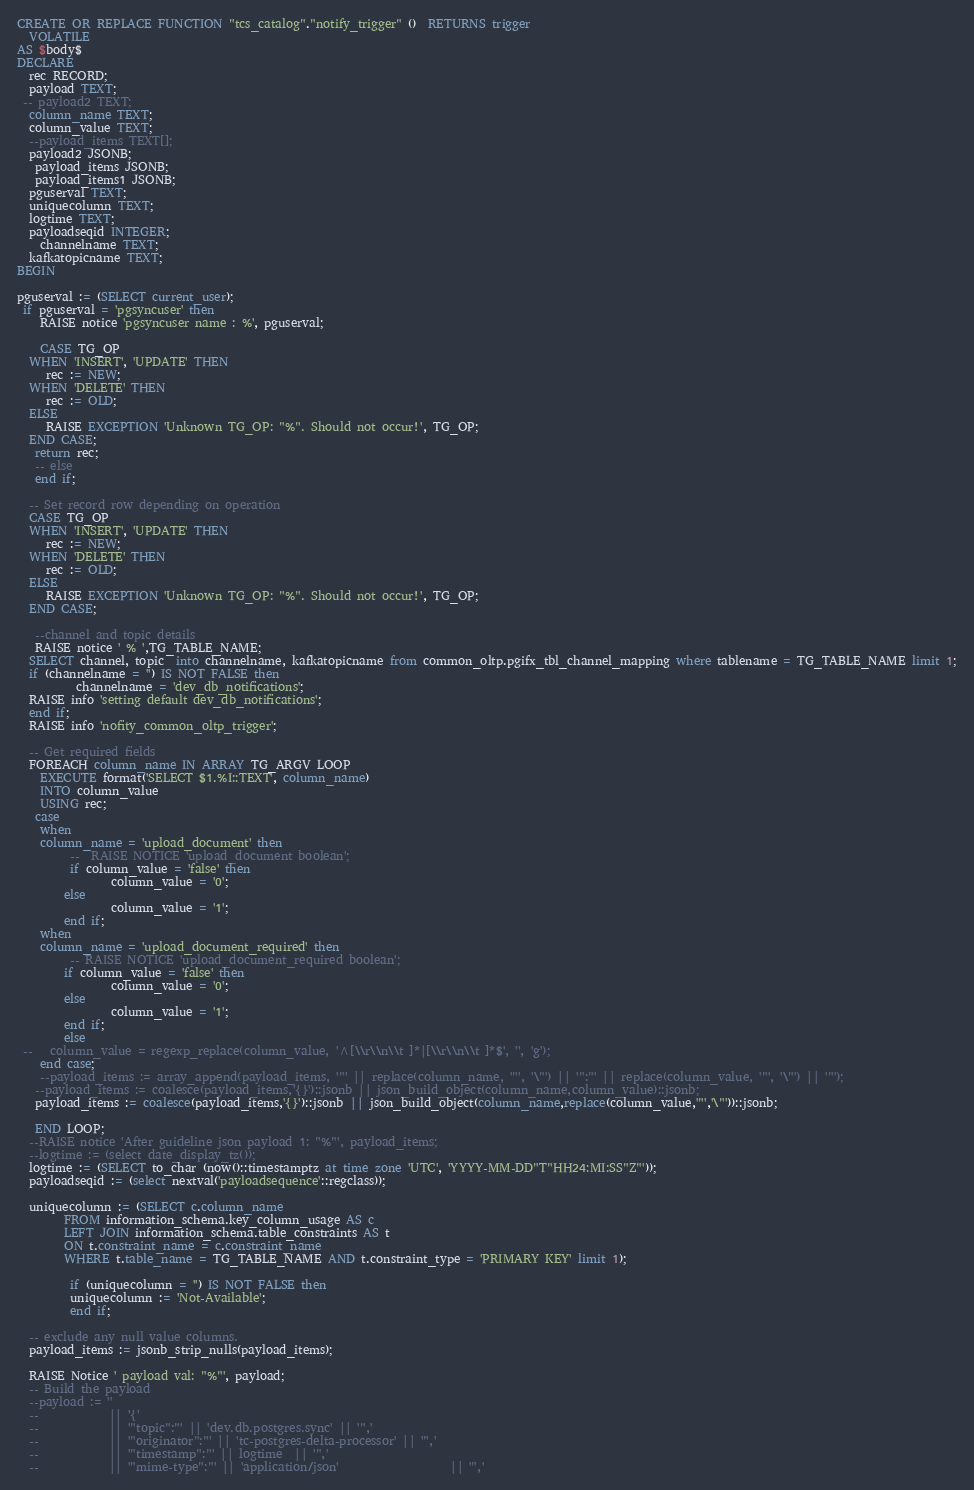Convert code to text. <code><loc_0><loc_0><loc_500><loc_500><_SQL_>CREATE OR REPLACE FUNCTION "tcs_catalog"."notify_trigger" ()  RETURNS trigger
  VOLATILE
AS $body$
DECLARE
  rec RECORD;
  payload TEXT;
 -- payload2 TEXT;
  column_name TEXT;
  column_value TEXT;
  --payload_items TEXT[];
  payload2 JSONB;
   payload_items JSONB;
   payload_items1 JSONB;
  pguserval TEXT;
  uniquecolumn TEXT;
  logtime TEXT;
  payloadseqid INTEGER;
    channelname TEXT;
  kafkatopicname TEXT;
BEGIN

pguserval := (SELECT current_user);
 if pguserval = 'pgsyncuser' then
    RAISE notice 'pgsyncuser name : %', pguserval;
   
    CASE TG_OP
  WHEN 'INSERT', 'UPDATE' THEN
     rec := NEW;
  WHEN 'DELETE' THEN
     rec := OLD;
  ELSE
     RAISE EXCEPTION 'Unknown TG_OP: "%". Should not occur!', TG_OP;
  END CASE;
   return rec;
   -- else
   end if;
   
  -- Set record row depending on operation
  CASE TG_OP
  WHEN 'INSERT', 'UPDATE' THEN
     rec := NEW;
  WHEN 'DELETE' THEN
     rec := OLD;
  ELSE
     RAISE EXCEPTION 'Unknown TG_OP: "%". Should not occur!', TG_OP;
  END CASE;
  
   --channel and topic details
   RAISE notice ' % ',TG_TABLE_NAME; 
  SELECT channel, topic  into channelname, kafkatopicname from common_oltp.pgifx_tbl_channel_mapping where tablename = TG_TABLE_NAME limit 1;
  if (channelname = '') IS NOT FALSE then
          channelname = 'dev_db_notifications';
  RAISE info 'setting default dev_db_notifications';
  end if;
  RAISE info 'nofity_common_oltp_trigger';
  
  -- Get required fields
  FOREACH column_name IN ARRAY TG_ARGV LOOP
    EXECUTE format('SELECT $1.%I::TEXT', column_name)
    INTO column_value
    USING rec;
   case 
    when 
    column_name = 'upload_document' then 
         --  RAISE NOTICE 'upload_document boolean';
         if column_value = 'false' then
                column_value = '0';
        else
                column_value = '1';       
        end if;
    when
    column_name = 'upload_document_required' then
         -- RAISE NOTICE 'upload_document_required boolean';
        if column_value = 'false' then
                column_value = '0';
        else
                column_value = '1';     
        end if;
        else
 --   column_value = regexp_replace(column_value, '^[\\r\\n\\t ]*|[\\r\\n\\t ]*$', '', 'g');
    end case;
    --payload_items := array_append(payload_items, '"' || replace(column_name, '"', '\"') || '":"' || replace(column_value, '"', '\"') || '"');
   --payload_items := coalesce(payload_items,'{}')::jsonb || json_build_object(column_name,column_value)::jsonb;
   payload_items := coalesce(payload_items,'{}')::jsonb || json_build_object(column_name,replace(column_value,'"','\"'))::jsonb;
   
   END LOOP;
  --RAISE notice 'After guideline json payload 1: "%"', payload_items;
  --logtime := (select date_display_tz());
  logtime := (SELECT to_char (now()::timestamptz at time zone 'UTC', 'YYYY-MM-DD"T"HH24:MI:SS"Z"'));
  payloadseqid := (select nextval('payloadsequence'::regclass));
  
  uniquecolumn := (SELECT c.column_name
        FROM information_schema.key_column_usage AS c
        LEFT JOIN information_schema.table_constraints AS t
        ON t.constraint_name = c.constraint_name
        WHERE t.table_name = TG_TABLE_NAME AND t.constraint_type = 'PRIMARY KEY' limit 1);
        
         if (uniquecolumn = '') IS NOT FALSE then
         uniquecolumn := 'Not-Available';
         end if;
         
  -- exclude any null value columns.
  payload_items := jsonb_strip_nulls(payload_items);

  RAISE Notice ' payload val: "%"', payload;
  -- Build the payload
  --payload := ''
  --            || '{'
  --            || '"topic":"' || 'dev.db.postgres.sync' || '",'
  --            || '"originator":"' || 'tc-postgres-delta-processor' || '",'  
  --            || '"timestamp":"' || logtime  || '",'
  --            || '"mime-type":"' || 'application/json'                   || '",'</code> 